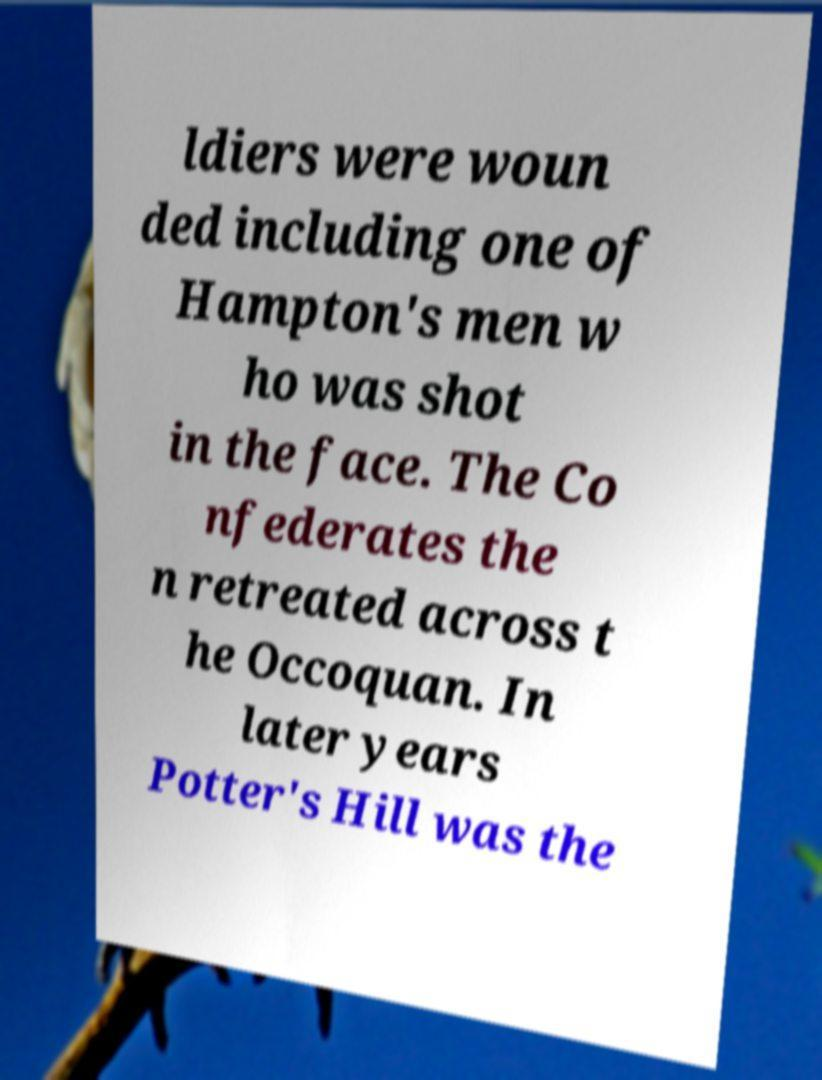Can you accurately transcribe the text from the provided image for me? ldiers were woun ded including one of Hampton's men w ho was shot in the face. The Co nfederates the n retreated across t he Occoquan. In later years Potter's Hill was the 